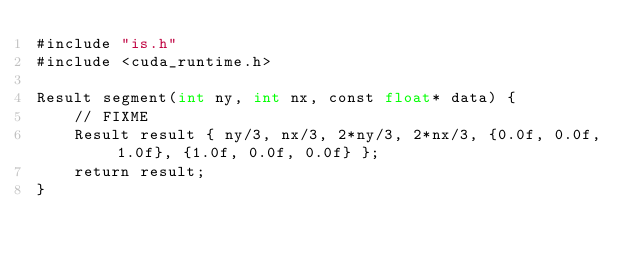<code> <loc_0><loc_0><loc_500><loc_500><_Cuda_>#include "is.h"
#include <cuda_runtime.h>

Result segment(int ny, int nx, const float* data) {
    // FIXME
    Result result { ny/3, nx/3, 2*ny/3, 2*nx/3, {0.0f, 0.0f, 1.0f}, {1.0f, 0.0f, 0.0f} };
    return result;
}
</code> 